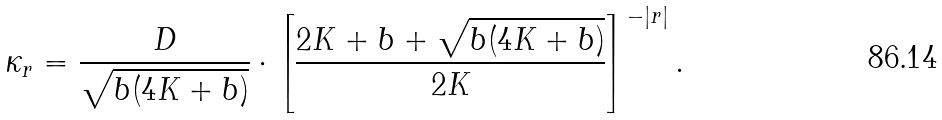<formula> <loc_0><loc_0><loc_500><loc_500>\kappa _ { r } = \frac { D } { { \sqrt { b ( 4 K + b ) } } } \cdot \left [ { \frac { { 2 K + b + \sqrt { b ( 4 K + b ) } } } { 2 K } } \right ] ^ { - \left | r \right | } .</formula> 